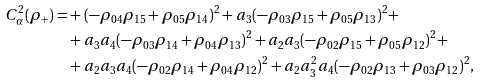<formula> <loc_0><loc_0><loc_500><loc_500>C ^ { 2 } _ { \alpha } ( \rho _ { + } ) = & + ( - \rho _ { 0 4 } \rho _ { 1 5 } + \rho _ { 0 5 } \rho _ { 1 4 } ) ^ { 2 } + a _ { 3 } ( - \rho _ { 0 3 } \rho _ { 1 5 } + \rho _ { 0 5 } \rho _ { 1 3 } ) ^ { 2 } + \\ & + a _ { 3 } a _ { 4 } ( - \rho _ { 0 3 } \rho _ { 1 4 } + \rho _ { 0 4 } \rho _ { 1 3 } ) ^ { 2 } + a _ { 2 } a _ { 3 } ( - \rho _ { 0 2 } \rho _ { 1 5 } + \rho _ { 0 5 } \rho _ { 1 2 } ) ^ { 2 } + \\ & + a _ { 2 } a _ { 3 } a _ { 4 } ( - \rho _ { 0 2 } \rho _ { 1 4 } + \rho _ { 0 4 } \rho _ { 1 2 } ) ^ { 2 } + a _ { 2 } a _ { 3 } ^ { 2 } a _ { 4 } ( - \rho _ { 0 2 } \rho _ { 1 3 } + \rho _ { 0 3 } \rho _ { 1 2 } ) ^ { 2 } ,</formula> 